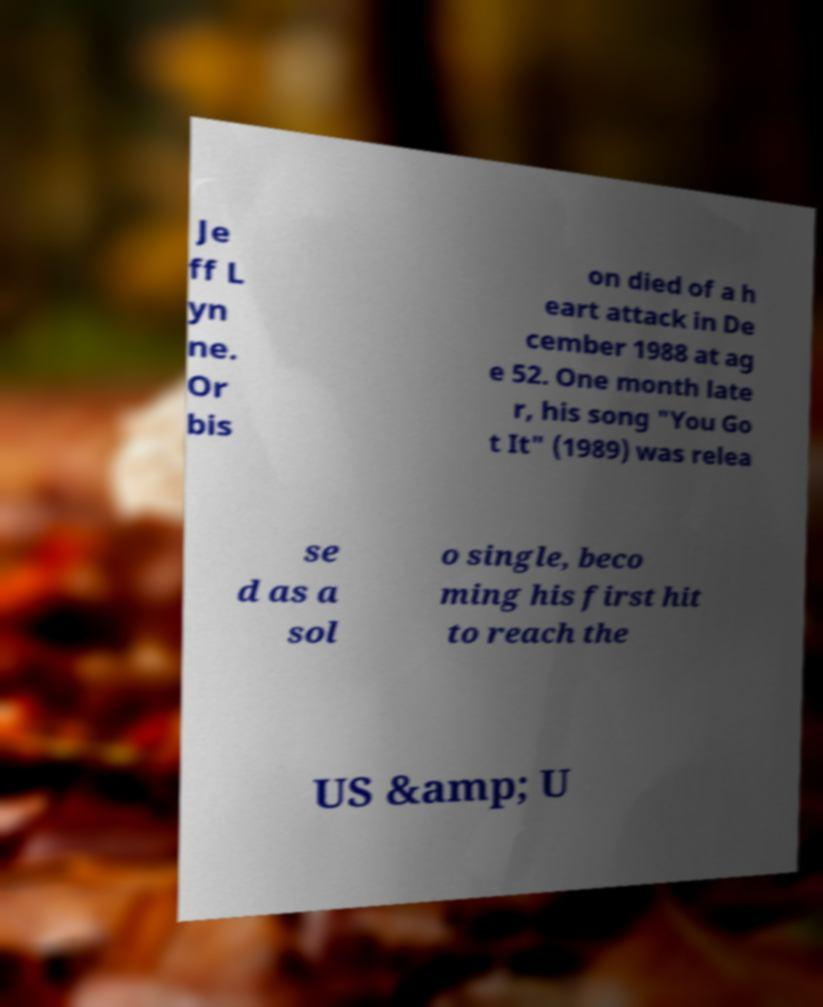Could you extract and type out the text from this image? Je ff L yn ne. Or bis on died of a h eart attack in De cember 1988 at ag e 52. One month late r, his song "You Go t It" (1989) was relea se d as a sol o single, beco ming his first hit to reach the US &amp; U 